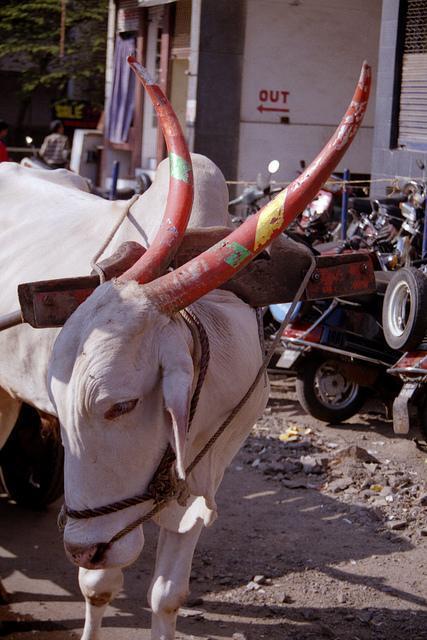How many animals are depicted?
Give a very brief answer. 1. How many horns are visible?
Give a very brief answer. 2. How many motorcycles are in the picture?
Give a very brief answer. 3. How many train cars are visible?
Give a very brief answer. 0. 